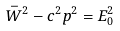Convert formula to latex. <formula><loc_0><loc_0><loc_500><loc_500>\bar { W } ^ { 2 } - c ^ { 2 } p ^ { 2 } = E _ { 0 } ^ { 2 }</formula> 